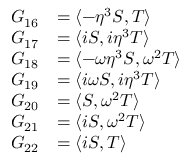Convert formula to latex. <formula><loc_0><loc_0><loc_500><loc_500>\begin{array} { r l } { G _ { 1 6 } } & { = \langle - \eta ^ { 3 } S , T \rangle } \\ { G _ { 1 7 } } & { = \langle i S , i \eta ^ { 3 } T \rangle } \\ { G _ { 1 8 } } & { = \langle - \omega \eta ^ { 3 } S , \omega ^ { 2 } T \rangle } \\ { G _ { 1 9 } } & { = \langle i \omega S , i \eta ^ { 3 } T \rangle } \\ { G _ { 2 0 } } & { = \langle S , \omega ^ { 2 } T \rangle } \\ { G _ { 2 1 } } & { = \langle i S , \omega ^ { 2 } T \rangle } \\ { G _ { 2 2 } } & { = \langle i S , T \rangle } \end{array}</formula> 